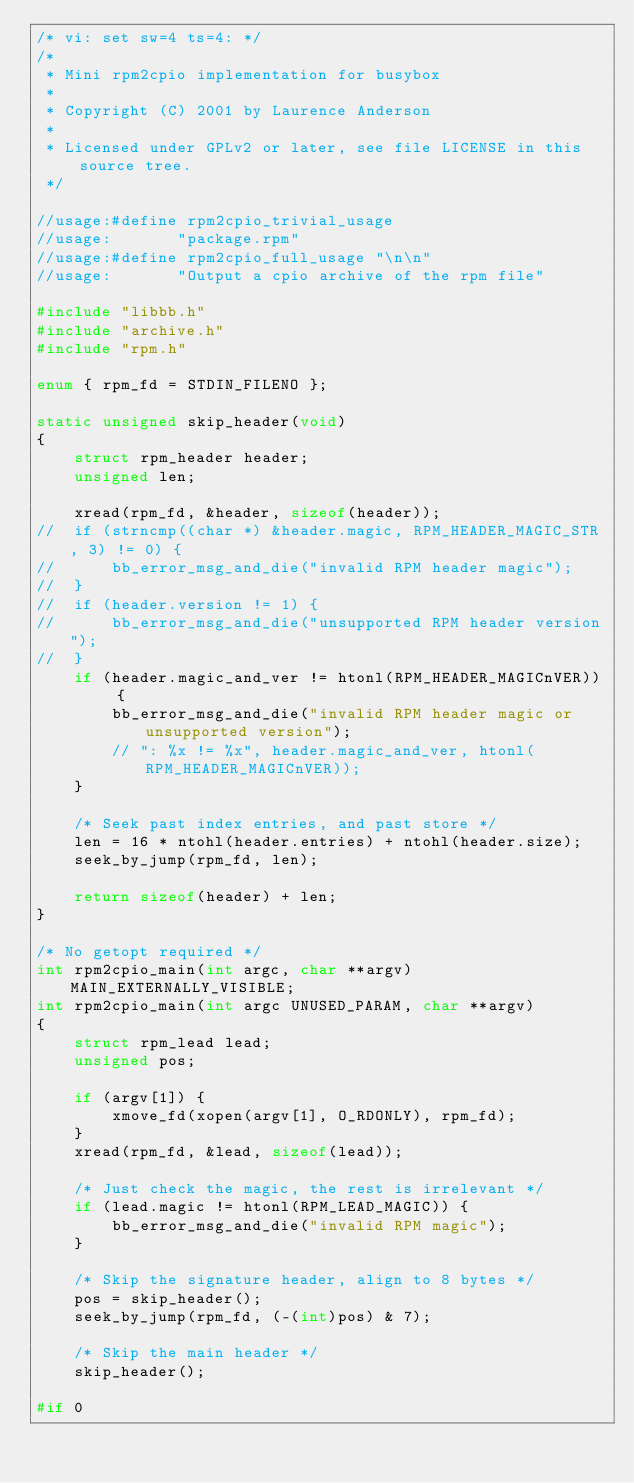<code> <loc_0><loc_0><loc_500><loc_500><_C_>/* vi: set sw=4 ts=4: */
/*
 * Mini rpm2cpio implementation for busybox
 *
 * Copyright (C) 2001 by Laurence Anderson
 *
 * Licensed under GPLv2 or later, see file LICENSE in this source tree.
 */

//usage:#define rpm2cpio_trivial_usage
//usage:       "package.rpm"
//usage:#define rpm2cpio_full_usage "\n\n"
//usage:       "Output a cpio archive of the rpm file"

#include "libbb.h"
#include "archive.h"
#include "rpm.h"

enum { rpm_fd = STDIN_FILENO };

static unsigned skip_header(void)
{
	struct rpm_header header;
	unsigned len;

	xread(rpm_fd, &header, sizeof(header));
//	if (strncmp((char *) &header.magic, RPM_HEADER_MAGIC_STR, 3) != 0) {
//		bb_error_msg_and_die("invalid RPM header magic");
//	}
//	if (header.version != 1) {
//		bb_error_msg_and_die("unsupported RPM header version");
//	}
	if (header.magic_and_ver != htonl(RPM_HEADER_MAGICnVER)) {
		bb_error_msg_and_die("invalid RPM header magic or unsupported version");
		// ": %x != %x", header.magic_and_ver, htonl(RPM_HEADER_MAGICnVER));
	}

	/* Seek past index entries, and past store */
	len = 16 * ntohl(header.entries) + ntohl(header.size);
	seek_by_jump(rpm_fd, len);

	return sizeof(header) + len;
}

/* No getopt required */
int rpm2cpio_main(int argc, char **argv) MAIN_EXTERNALLY_VISIBLE;
int rpm2cpio_main(int argc UNUSED_PARAM, char **argv)
{
	struct rpm_lead lead;
	unsigned pos;

	if (argv[1]) {
		xmove_fd(xopen(argv[1], O_RDONLY), rpm_fd);
	}
	xread(rpm_fd, &lead, sizeof(lead));

	/* Just check the magic, the rest is irrelevant */
	if (lead.magic != htonl(RPM_LEAD_MAGIC)) {
		bb_error_msg_and_die("invalid RPM magic");
	}

	/* Skip the signature header, align to 8 bytes */
	pos = skip_header();
	seek_by_jump(rpm_fd, (-(int)pos) & 7);

	/* Skip the main header */
	skip_header();

#if 0</code> 